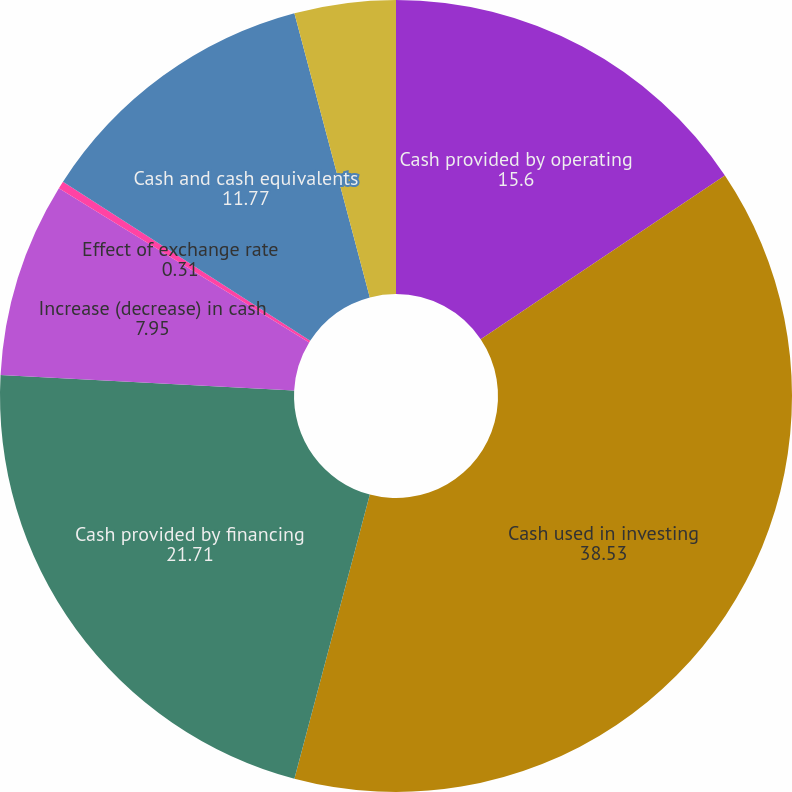<chart> <loc_0><loc_0><loc_500><loc_500><pie_chart><fcel>Cash provided by operating<fcel>Cash used in investing<fcel>Cash provided by financing<fcel>Increase (decrease) in cash<fcel>Effect of exchange rate<fcel>Cash and cash equivalents<fcel>Cash and cash equivalents end<nl><fcel>15.6%<fcel>38.53%<fcel>21.71%<fcel>7.95%<fcel>0.31%<fcel>11.77%<fcel>4.13%<nl></chart> 